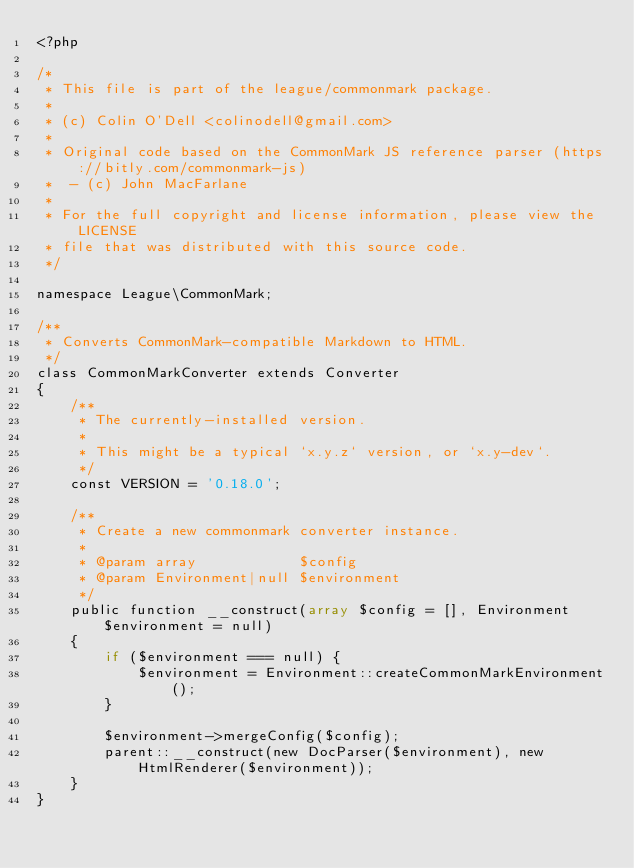<code> <loc_0><loc_0><loc_500><loc_500><_PHP_><?php

/*
 * This file is part of the league/commonmark package.
 *
 * (c) Colin O'Dell <colinodell@gmail.com>
 *
 * Original code based on the CommonMark JS reference parser (https://bitly.com/commonmark-js)
 *  - (c) John MacFarlane
 *
 * For the full copyright and license information, please view the LICENSE
 * file that was distributed with this source code.
 */

namespace League\CommonMark;

/**
 * Converts CommonMark-compatible Markdown to HTML.
 */
class CommonMarkConverter extends Converter
{
    /**
     * The currently-installed version.
     *
     * This might be a typical `x.y.z` version, or `x.y-dev`.
     */
    const VERSION = '0.18.0';

    /**
     * Create a new commonmark converter instance.
     *
     * @param array            $config
     * @param Environment|null $environment
     */
    public function __construct(array $config = [], Environment $environment = null)
    {
        if ($environment === null) {
            $environment = Environment::createCommonMarkEnvironment();
        }

        $environment->mergeConfig($config);
        parent::__construct(new DocParser($environment), new HtmlRenderer($environment));
    }
}
</code> 